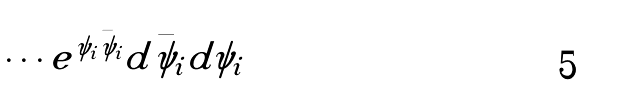<formula> <loc_0><loc_0><loc_500><loc_500>\int \cdots e ^ { \psi _ { i } \bar { \psi } _ { i } } d \bar { \psi } _ { i } d \psi _ { i }</formula> 